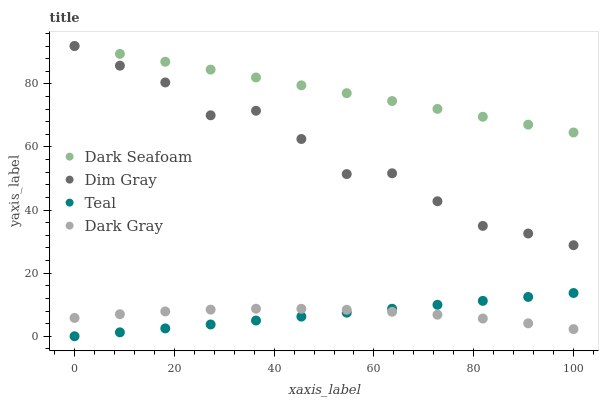Does Teal have the minimum area under the curve?
Answer yes or no. Yes. Does Dark Seafoam have the maximum area under the curve?
Answer yes or no. Yes. Does Dim Gray have the minimum area under the curve?
Answer yes or no. No. Does Dim Gray have the maximum area under the curve?
Answer yes or no. No. Is Teal the smoothest?
Answer yes or no. Yes. Is Dim Gray the roughest?
Answer yes or no. Yes. Is Dark Seafoam the smoothest?
Answer yes or no. No. Is Dark Seafoam the roughest?
Answer yes or no. No. Does Teal have the lowest value?
Answer yes or no. Yes. Does Dim Gray have the lowest value?
Answer yes or no. No. Does Dim Gray have the highest value?
Answer yes or no. Yes. Does Teal have the highest value?
Answer yes or no. No. Is Teal less than Dim Gray?
Answer yes or no. Yes. Is Dim Gray greater than Dark Gray?
Answer yes or no. Yes. Does Dim Gray intersect Dark Seafoam?
Answer yes or no. Yes. Is Dim Gray less than Dark Seafoam?
Answer yes or no. No. Is Dim Gray greater than Dark Seafoam?
Answer yes or no. No. Does Teal intersect Dim Gray?
Answer yes or no. No. 